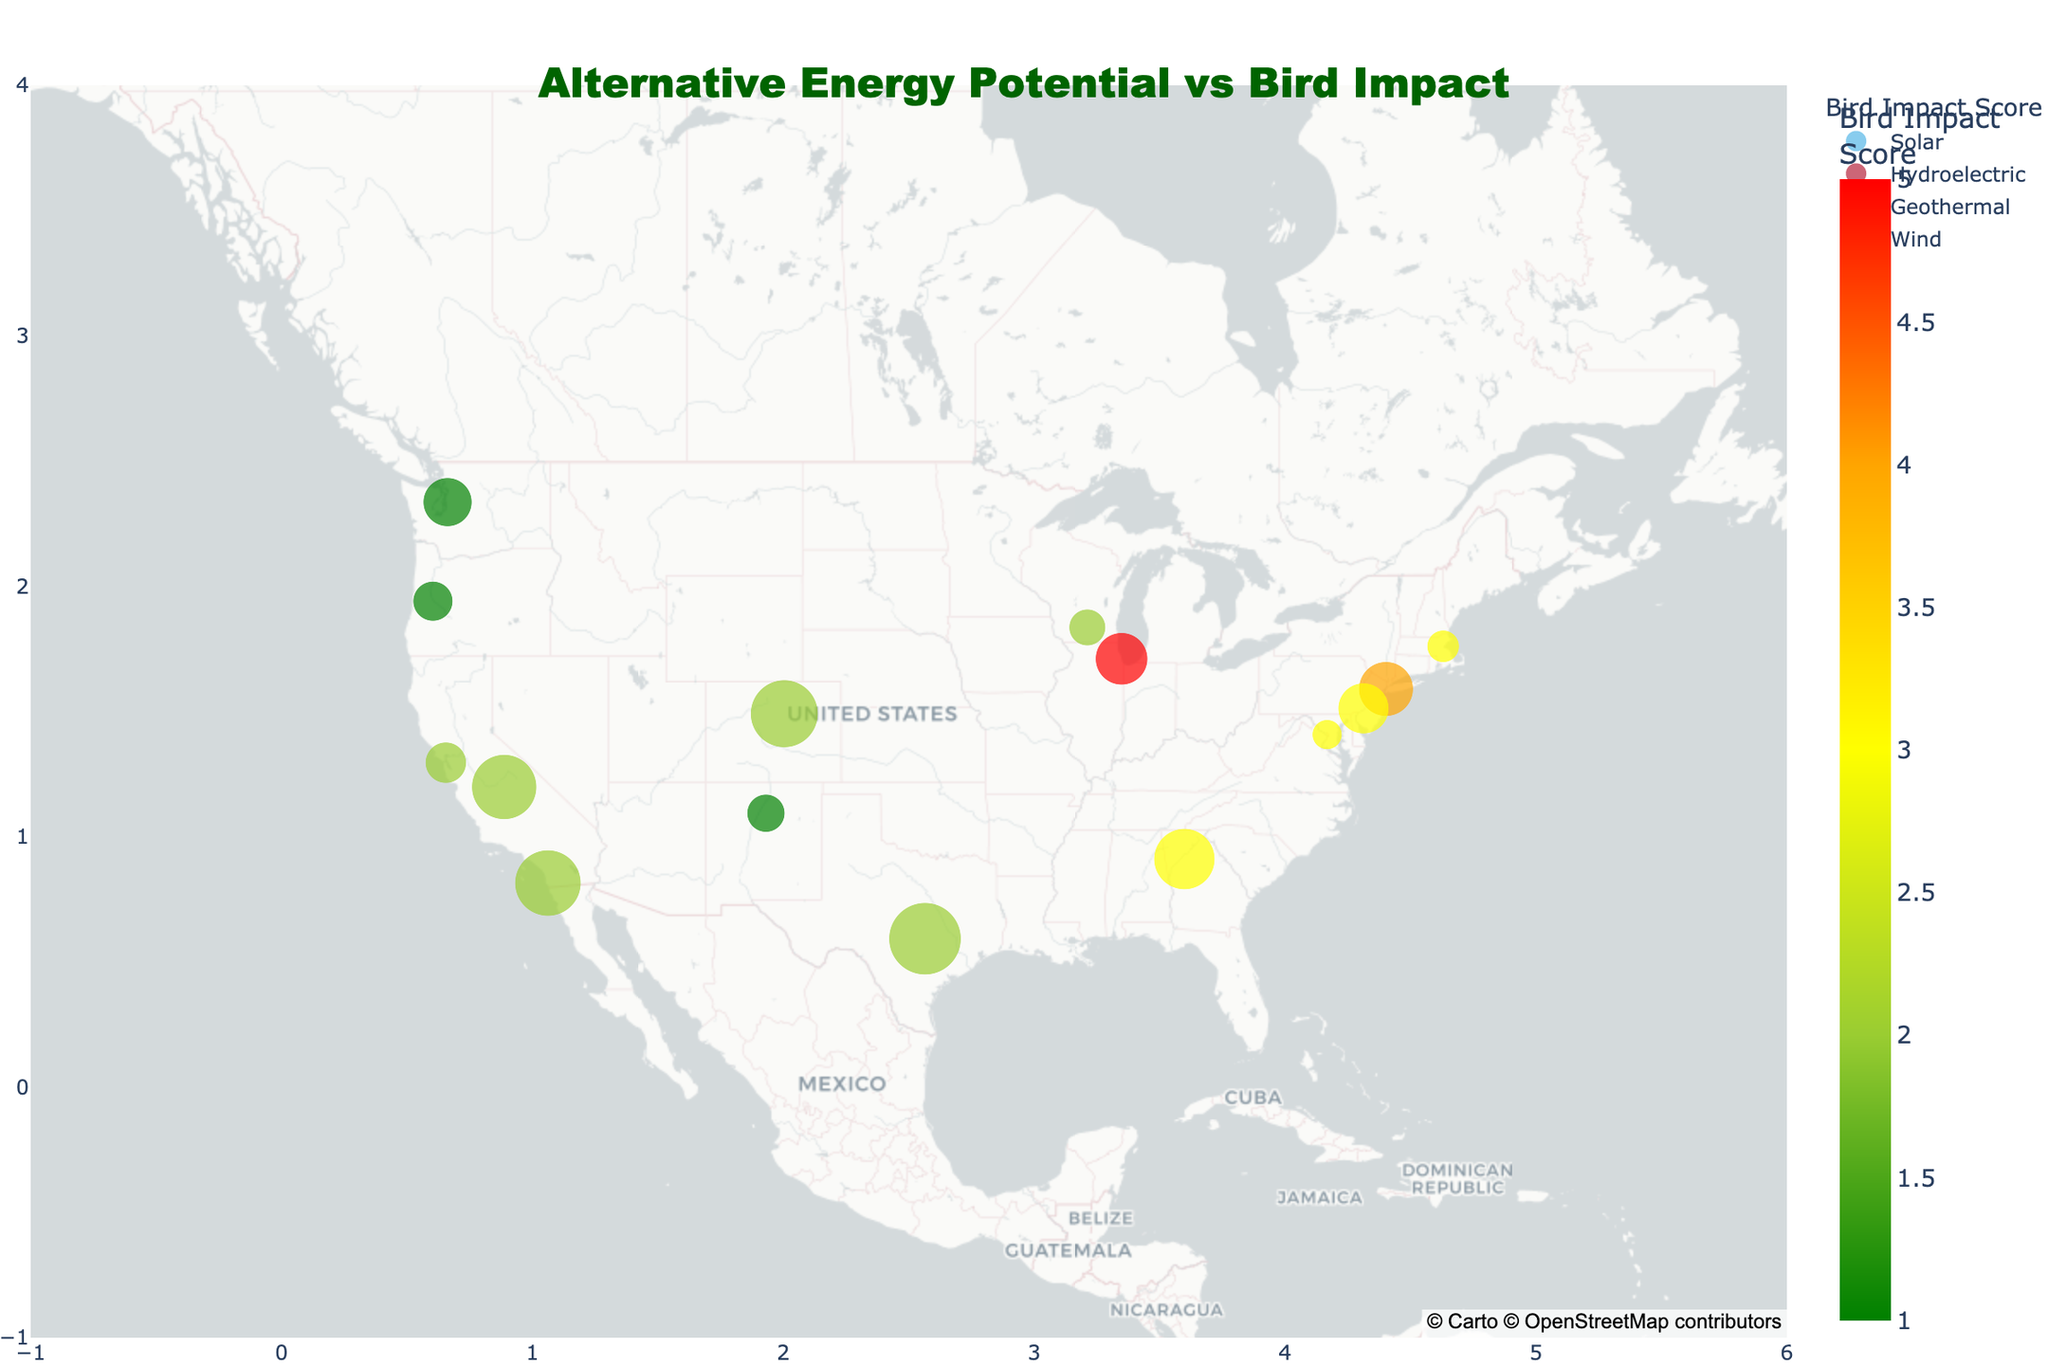What's the title of the figure? The figure's title is mentioned at the top of the map.
Answer: "Alternative Energy Potential vs Bird Impact" How many data points represent solar energy potential? Look for the data points with "Solar" in the hover label, filter out the other energy types.
Answer: 7 What location has the highest bird impact score? Identify the location with the highest numeric value in the Bird Impact Score from the color scale or legend.
Answer: Chicago, IL Which locations have a bird impact score of 1? Find and list all locations with the green color, corresponding to the score of 1.
Answer: Eugene, OR; Seattle, WA; Santa Fe, NM How does the potential MW for solar energy in Austin, TX compare to that in New York, NY? Compare the size of the bubbles for the two locations since size represents Potential MW.
Answer: Austin, TX has 1050 MW, more than New York, NY's 600 MW Which energy type appears most frequently in the figure? Determine which energy type is represented by the most data points.
Answer: Solar What's the average bird impact score for geothermal energy sites? Identify all geothermal sites, sum their Bird Impact Scores, and divide by the number of geothermal sites.
Answer: (3 + 3 + 1 + 2) / 4 = 2.25 Which location has the highest potential MW for hydroelectric energy? Find the largest bubble among those representing hydroelectric energy.
Answer: Seattle, WA Are there more solar energy sites with a bird impact score of 2 or 3? Count the number of solar energy sites with Bird Impact Scores of 2 and 3.
Answer: More with a score of 2 How many locations have both high potential MW (above 900) and a low bird impact score (2 or lower)? Identify the locations with Potential MW greater than 900 and Bird Impact Score of 2 or lower.
Answer: 3 locations (Fresno, CA; Denver, CO; Austin, TX) 